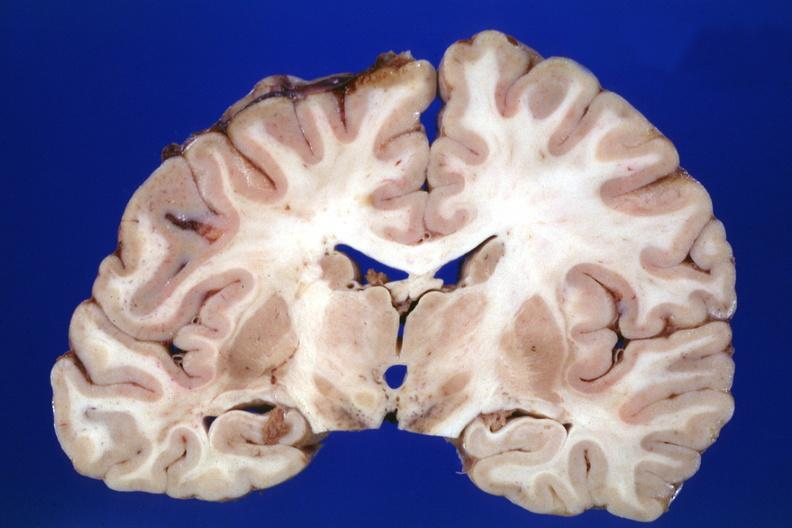was no tissue recognizable as ovary in the pons?
Answer the question using a single word or phrase. No 